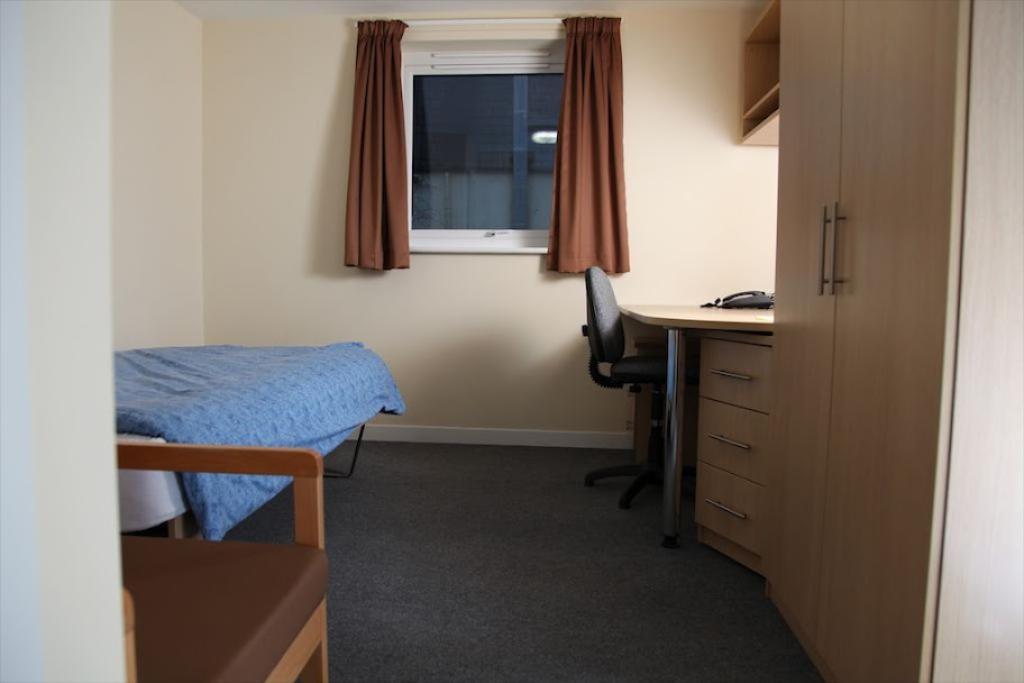In one or two sentences, can you explain what this image depicts? In the left bottom of the image, there is a chair half visible. Into the right side of the image, there is a cupboard. Next to that there is table and a desk is visible. In the background, there is a window on which brown color curtain is hanged. The wall is light in color. In the left middle of the image, there is a bed on which blue color mattress is placed. 